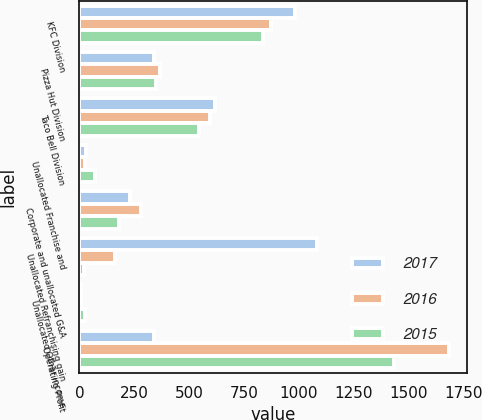<chart> <loc_0><loc_0><loc_500><loc_500><stacked_bar_chart><ecel><fcel>KFC Division<fcel>Pizza Hut Division<fcel>Taco Bell Division<fcel>Unallocated Franchise and<fcel>Corporate and unallocated G&A<fcel>Unallocated Refranchising gain<fcel>Unallocated Other income<fcel>Operating Profit<nl><fcel>2017<fcel>981<fcel>341<fcel>619<fcel>30<fcel>230<fcel>1083<fcel>8<fcel>341<nl><fcel>2016<fcel>871<fcel>367<fcel>595<fcel>24<fcel>280<fcel>163<fcel>8<fcel>1682<nl><fcel>2015<fcel>835<fcel>351<fcel>546<fcel>71<fcel>180<fcel>23<fcel>24<fcel>1434<nl></chart> 